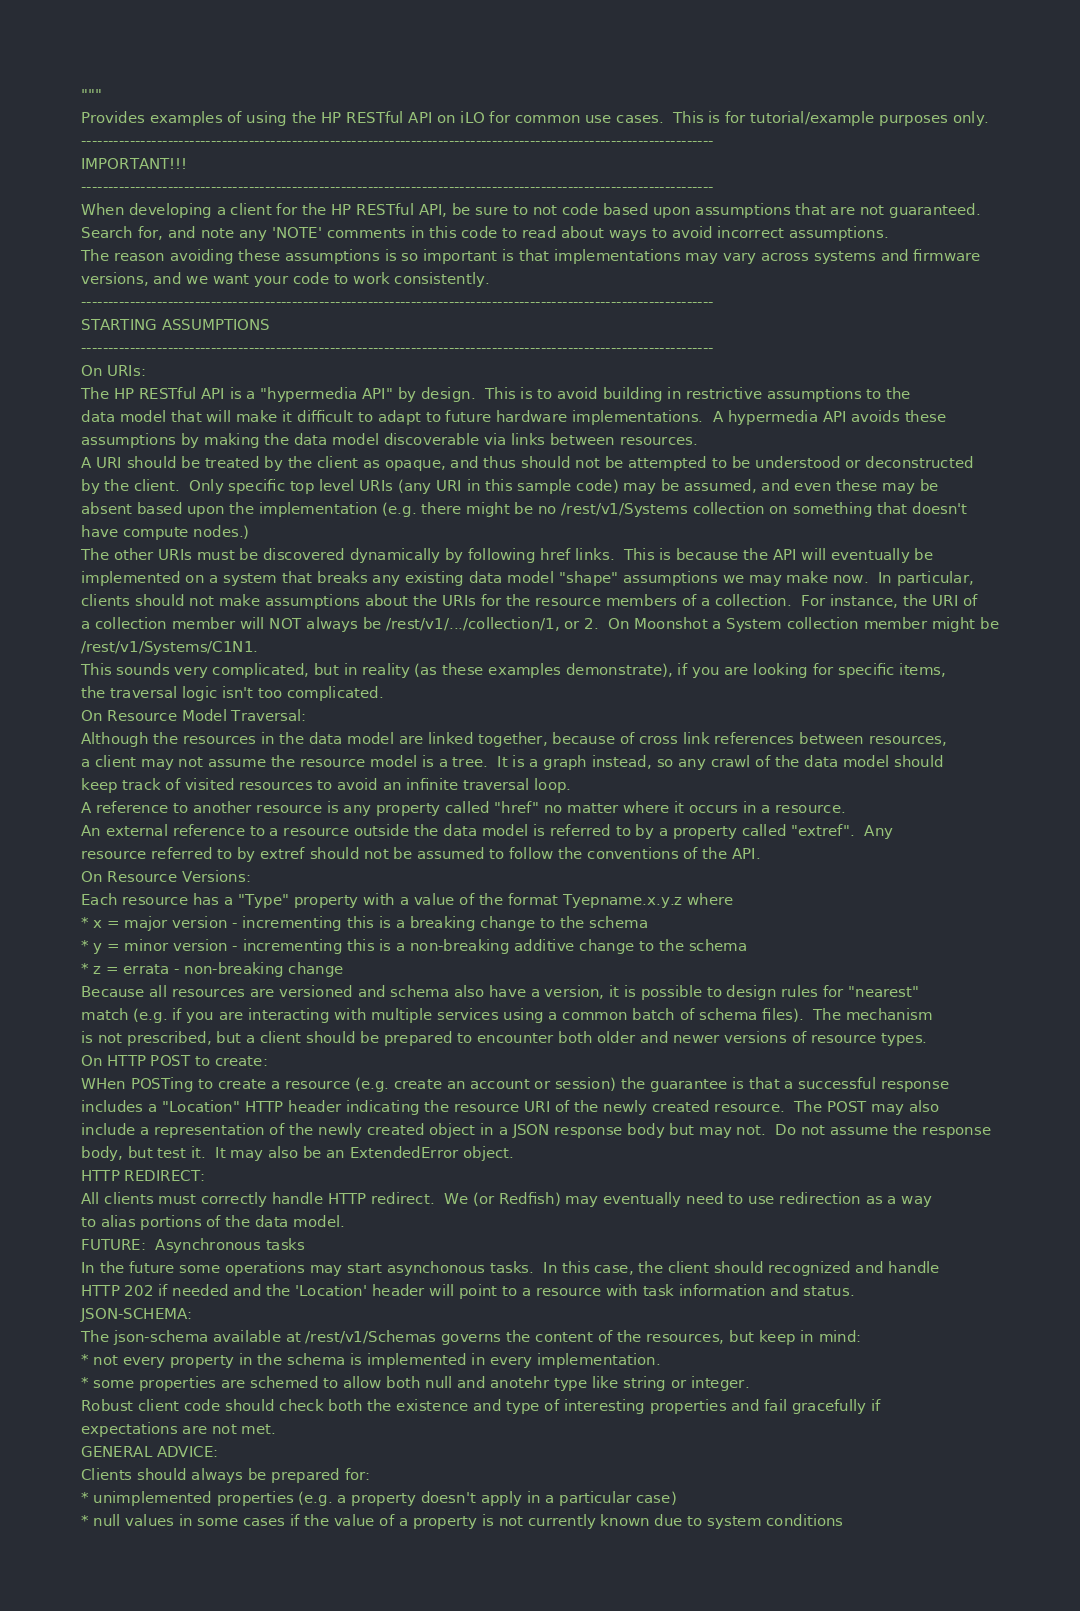<code> <loc_0><loc_0><loc_500><loc_500><_Python_>"""
Provides examples of using the HP RESTful API on iLO for common use cases.  This is for tutorial/example purposes only.
---------------------------------------------------------------------------------------------------------------------
IMPORTANT!!!
---------------------------------------------------------------------------------------------------------------------
When developing a client for the HP RESTful API, be sure to not code based upon assumptions that are not guaranteed.
Search for, and note any 'NOTE' comments in this code to read about ways to avoid incorrect assumptions.
The reason avoiding these assumptions is so important is that implementations may vary across systems and firmware
versions, and we want your code to work consistently.
---------------------------------------------------------------------------------------------------------------------
STARTING ASSUMPTIONS
---------------------------------------------------------------------------------------------------------------------
On URIs:
The HP RESTful API is a "hypermedia API" by design.  This is to avoid building in restrictive assumptions to the
data model that will make it difficult to adapt to future hardware implementations.  A hypermedia API avoids these
assumptions by making the data model discoverable via links between resources.
A URI should be treated by the client as opaque, and thus should not be attempted to be understood or deconstructed
by the client.  Only specific top level URIs (any URI in this sample code) may be assumed, and even these may be
absent based upon the implementation (e.g. there might be no /rest/v1/Systems collection on something that doesn't
have compute nodes.)
The other URIs must be discovered dynamically by following href links.  This is because the API will eventually be
implemented on a system that breaks any existing data model "shape" assumptions we may make now.  In particular,
clients should not make assumptions about the URIs for the resource members of a collection.  For instance, the URI of
a collection member will NOT always be /rest/v1/.../collection/1, or 2.  On Moonshot a System collection member might be
/rest/v1/Systems/C1N1.
This sounds very complicated, but in reality (as these examples demonstrate), if you are looking for specific items,
the traversal logic isn't too complicated.
On Resource Model Traversal:
Although the resources in the data model are linked together, because of cross link references between resources,
a client may not assume the resource model is a tree.  It is a graph instead, so any crawl of the data model should
keep track of visited resources to avoid an infinite traversal loop.
A reference to another resource is any property called "href" no matter where it occurs in a resource.
An external reference to a resource outside the data model is referred to by a property called "extref".  Any
resource referred to by extref should not be assumed to follow the conventions of the API.
On Resource Versions:
Each resource has a "Type" property with a value of the format Tyepname.x.y.z where
* x = major version - incrementing this is a breaking change to the schema
* y = minor version - incrementing this is a non-breaking additive change to the schema
* z = errata - non-breaking change
Because all resources are versioned and schema also have a version, it is possible to design rules for "nearest"
match (e.g. if you are interacting with multiple services using a common batch of schema files).  The mechanism
is not prescribed, but a client should be prepared to encounter both older and newer versions of resource types.
On HTTP POST to create:
WHen POSTing to create a resource (e.g. create an account or session) the guarantee is that a successful response
includes a "Location" HTTP header indicating the resource URI of the newly created resource.  The POST may also
include a representation of the newly created object in a JSON response body but may not.  Do not assume the response
body, but test it.  It may also be an ExtendedError object.
HTTP REDIRECT:
All clients must correctly handle HTTP redirect.  We (or Redfish) may eventually need to use redirection as a way
to alias portions of the data model.
FUTURE:  Asynchronous tasks
In the future some operations may start asynchonous tasks.  In this case, the client should recognized and handle
HTTP 202 if needed and the 'Location' header will point to a resource with task information and status.
JSON-SCHEMA:
The json-schema available at /rest/v1/Schemas governs the content of the resources, but keep in mind:
* not every property in the schema is implemented in every implementation.
* some properties are schemed to allow both null and anotehr type like string or integer.
Robust client code should check both the existence and type of interesting properties and fail gracefully if
expectations are not met.
GENERAL ADVICE:
Clients should always be prepared for:
* unimplemented properties (e.g. a property doesn't apply in a particular case)
* null values in some cases if the value of a property is not currently known due to system conditions</code> 